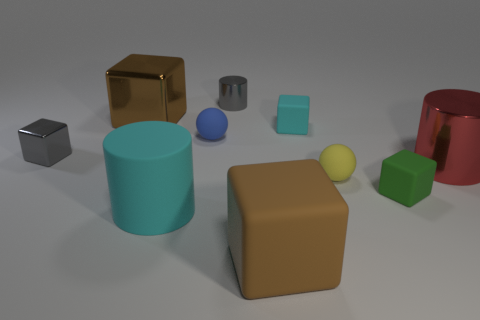Subtract all brown blocks. How many were subtracted if there are1brown blocks left? 1 Subtract 1 cylinders. How many cylinders are left? 2 Subtract all shiny cylinders. How many cylinders are left? 1 Subtract all brown cubes. How many cubes are left? 3 Subtract all green cylinders. Subtract all red balls. How many cylinders are left? 3 Subtract all cylinders. How many objects are left? 7 Subtract 1 green blocks. How many objects are left? 9 Subtract all large brown things. Subtract all red metal objects. How many objects are left? 7 Add 1 tiny shiny cylinders. How many tiny shiny cylinders are left? 2 Add 1 cylinders. How many cylinders exist? 4 